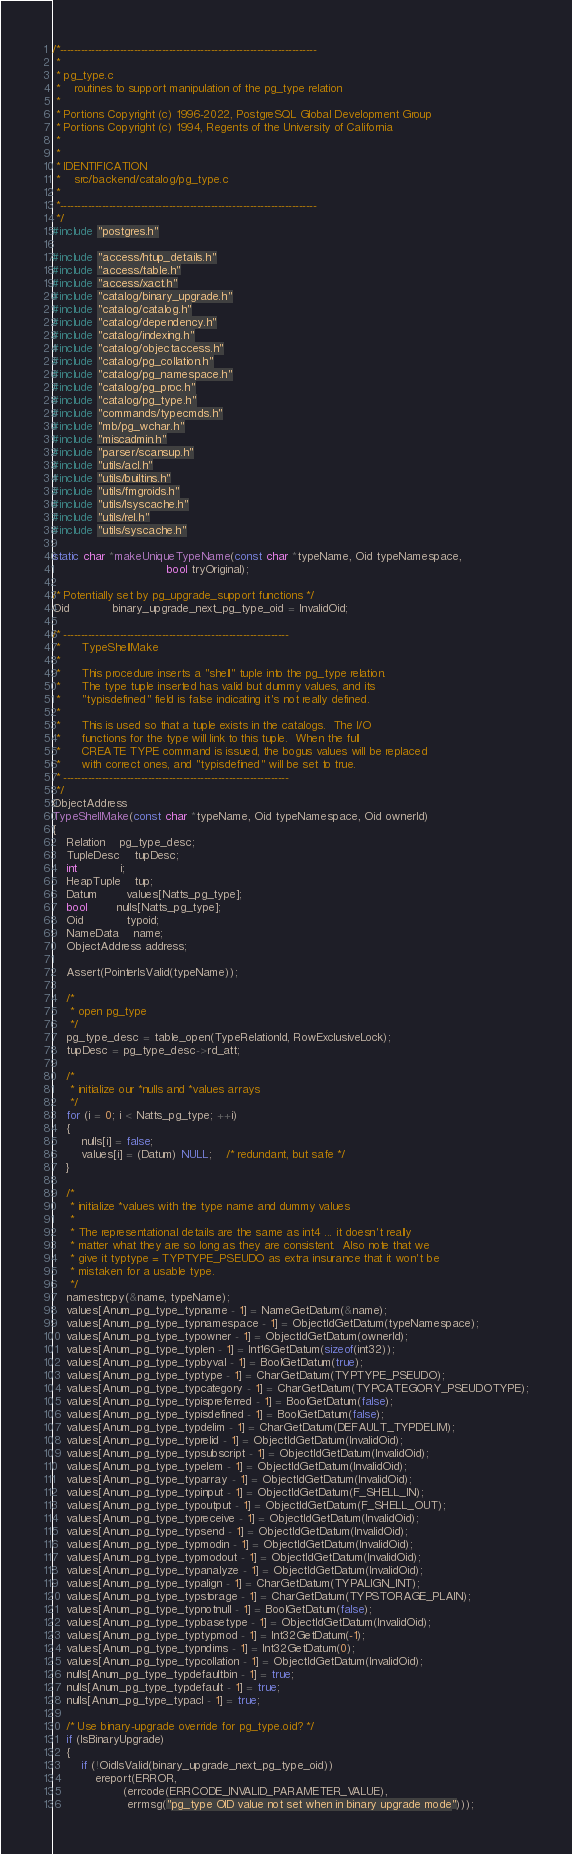<code> <loc_0><loc_0><loc_500><loc_500><_C_>/*-------------------------------------------------------------------------
 *
 * pg_type.c
 *	  routines to support manipulation of the pg_type relation
 *
 * Portions Copyright (c) 1996-2022, PostgreSQL Global Development Group
 * Portions Copyright (c) 1994, Regents of the University of California
 *
 *
 * IDENTIFICATION
 *	  src/backend/catalog/pg_type.c
 *
 *-------------------------------------------------------------------------
 */
#include "postgres.h"

#include "access/htup_details.h"
#include "access/table.h"
#include "access/xact.h"
#include "catalog/binary_upgrade.h"
#include "catalog/catalog.h"
#include "catalog/dependency.h"
#include "catalog/indexing.h"
#include "catalog/objectaccess.h"
#include "catalog/pg_collation.h"
#include "catalog/pg_namespace.h"
#include "catalog/pg_proc.h"
#include "catalog/pg_type.h"
#include "commands/typecmds.h"
#include "mb/pg_wchar.h"
#include "miscadmin.h"
#include "parser/scansup.h"
#include "utils/acl.h"
#include "utils/builtins.h"
#include "utils/fmgroids.h"
#include "utils/lsyscache.h"
#include "utils/rel.h"
#include "utils/syscache.h"

static char *makeUniqueTypeName(const char *typeName, Oid typeNamespace,
								bool tryOriginal);

/* Potentially set by pg_upgrade_support functions */
Oid			binary_upgrade_next_pg_type_oid = InvalidOid;

/* ----------------------------------------------------------------
 *		TypeShellMake
 *
 *		This procedure inserts a "shell" tuple into the pg_type relation.
 *		The type tuple inserted has valid but dummy values, and its
 *		"typisdefined" field is false indicating it's not really defined.
 *
 *		This is used so that a tuple exists in the catalogs.  The I/O
 *		functions for the type will link to this tuple.  When the full
 *		CREATE TYPE command is issued, the bogus values will be replaced
 *		with correct ones, and "typisdefined" will be set to true.
 * ----------------------------------------------------------------
 */
ObjectAddress
TypeShellMake(const char *typeName, Oid typeNamespace, Oid ownerId)
{
	Relation	pg_type_desc;
	TupleDesc	tupDesc;
	int			i;
	HeapTuple	tup;
	Datum		values[Natts_pg_type];
	bool		nulls[Natts_pg_type];
	Oid			typoid;
	NameData	name;
	ObjectAddress address;

	Assert(PointerIsValid(typeName));

	/*
	 * open pg_type
	 */
	pg_type_desc = table_open(TypeRelationId, RowExclusiveLock);
	tupDesc = pg_type_desc->rd_att;

	/*
	 * initialize our *nulls and *values arrays
	 */
	for (i = 0; i < Natts_pg_type; ++i)
	{
		nulls[i] = false;
		values[i] = (Datum) NULL;	/* redundant, but safe */
	}

	/*
	 * initialize *values with the type name and dummy values
	 *
	 * The representational details are the same as int4 ... it doesn't really
	 * matter what they are so long as they are consistent.  Also note that we
	 * give it typtype = TYPTYPE_PSEUDO as extra insurance that it won't be
	 * mistaken for a usable type.
	 */
	namestrcpy(&name, typeName);
	values[Anum_pg_type_typname - 1] = NameGetDatum(&name);
	values[Anum_pg_type_typnamespace - 1] = ObjectIdGetDatum(typeNamespace);
	values[Anum_pg_type_typowner - 1] = ObjectIdGetDatum(ownerId);
	values[Anum_pg_type_typlen - 1] = Int16GetDatum(sizeof(int32));
	values[Anum_pg_type_typbyval - 1] = BoolGetDatum(true);
	values[Anum_pg_type_typtype - 1] = CharGetDatum(TYPTYPE_PSEUDO);
	values[Anum_pg_type_typcategory - 1] = CharGetDatum(TYPCATEGORY_PSEUDOTYPE);
	values[Anum_pg_type_typispreferred - 1] = BoolGetDatum(false);
	values[Anum_pg_type_typisdefined - 1] = BoolGetDatum(false);
	values[Anum_pg_type_typdelim - 1] = CharGetDatum(DEFAULT_TYPDELIM);
	values[Anum_pg_type_typrelid - 1] = ObjectIdGetDatum(InvalidOid);
	values[Anum_pg_type_typsubscript - 1] = ObjectIdGetDatum(InvalidOid);
	values[Anum_pg_type_typelem - 1] = ObjectIdGetDatum(InvalidOid);
	values[Anum_pg_type_typarray - 1] = ObjectIdGetDatum(InvalidOid);
	values[Anum_pg_type_typinput - 1] = ObjectIdGetDatum(F_SHELL_IN);
	values[Anum_pg_type_typoutput - 1] = ObjectIdGetDatum(F_SHELL_OUT);
	values[Anum_pg_type_typreceive - 1] = ObjectIdGetDatum(InvalidOid);
	values[Anum_pg_type_typsend - 1] = ObjectIdGetDatum(InvalidOid);
	values[Anum_pg_type_typmodin - 1] = ObjectIdGetDatum(InvalidOid);
	values[Anum_pg_type_typmodout - 1] = ObjectIdGetDatum(InvalidOid);
	values[Anum_pg_type_typanalyze - 1] = ObjectIdGetDatum(InvalidOid);
	values[Anum_pg_type_typalign - 1] = CharGetDatum(TYPALIGN_INT);
	values[Anum_pg_type_typstorage - 1] = CharGetDatum(TYPSTORAGE_PLAIN);
	values[Anum_pg_type_typnotnull - 1] = BoolGetDatum(false);
	values[Anum_pg_type_typbasetype - 1] = ObjectIdGetDatum(InvalidOid);
	values[Anum_pg_type_typtypmod - 1] = Int32GetDatum(-1);
	values[Anum_pg_type_typndims - 1] = Int32GetDatum(0);
	values[Anum_pg_type_typcollation - 1] = ObjectIdGetDatum(InvalidOid);
	nulls[Anum_pg_type_typdefaultbin - 1] = true;
	nulls[Anum_pg_type_typdefault - 1] = true;
	nulls[Anum_pg_type_typacl - 1] = true;

	/* Use binary-upgrade override for pg_type.oid? */
	if (IsBinaryUpgrade)
	{
		if (!OidIsValid(binary_upgrade_next_pg_type_oid))
			ereport(ERROR,
					(errcode(ERRCODE_INVALID_PARAMETER_VALUE),
					 errmsg("pg_type OID value not set when in binary upgrade mode")));
</code> 